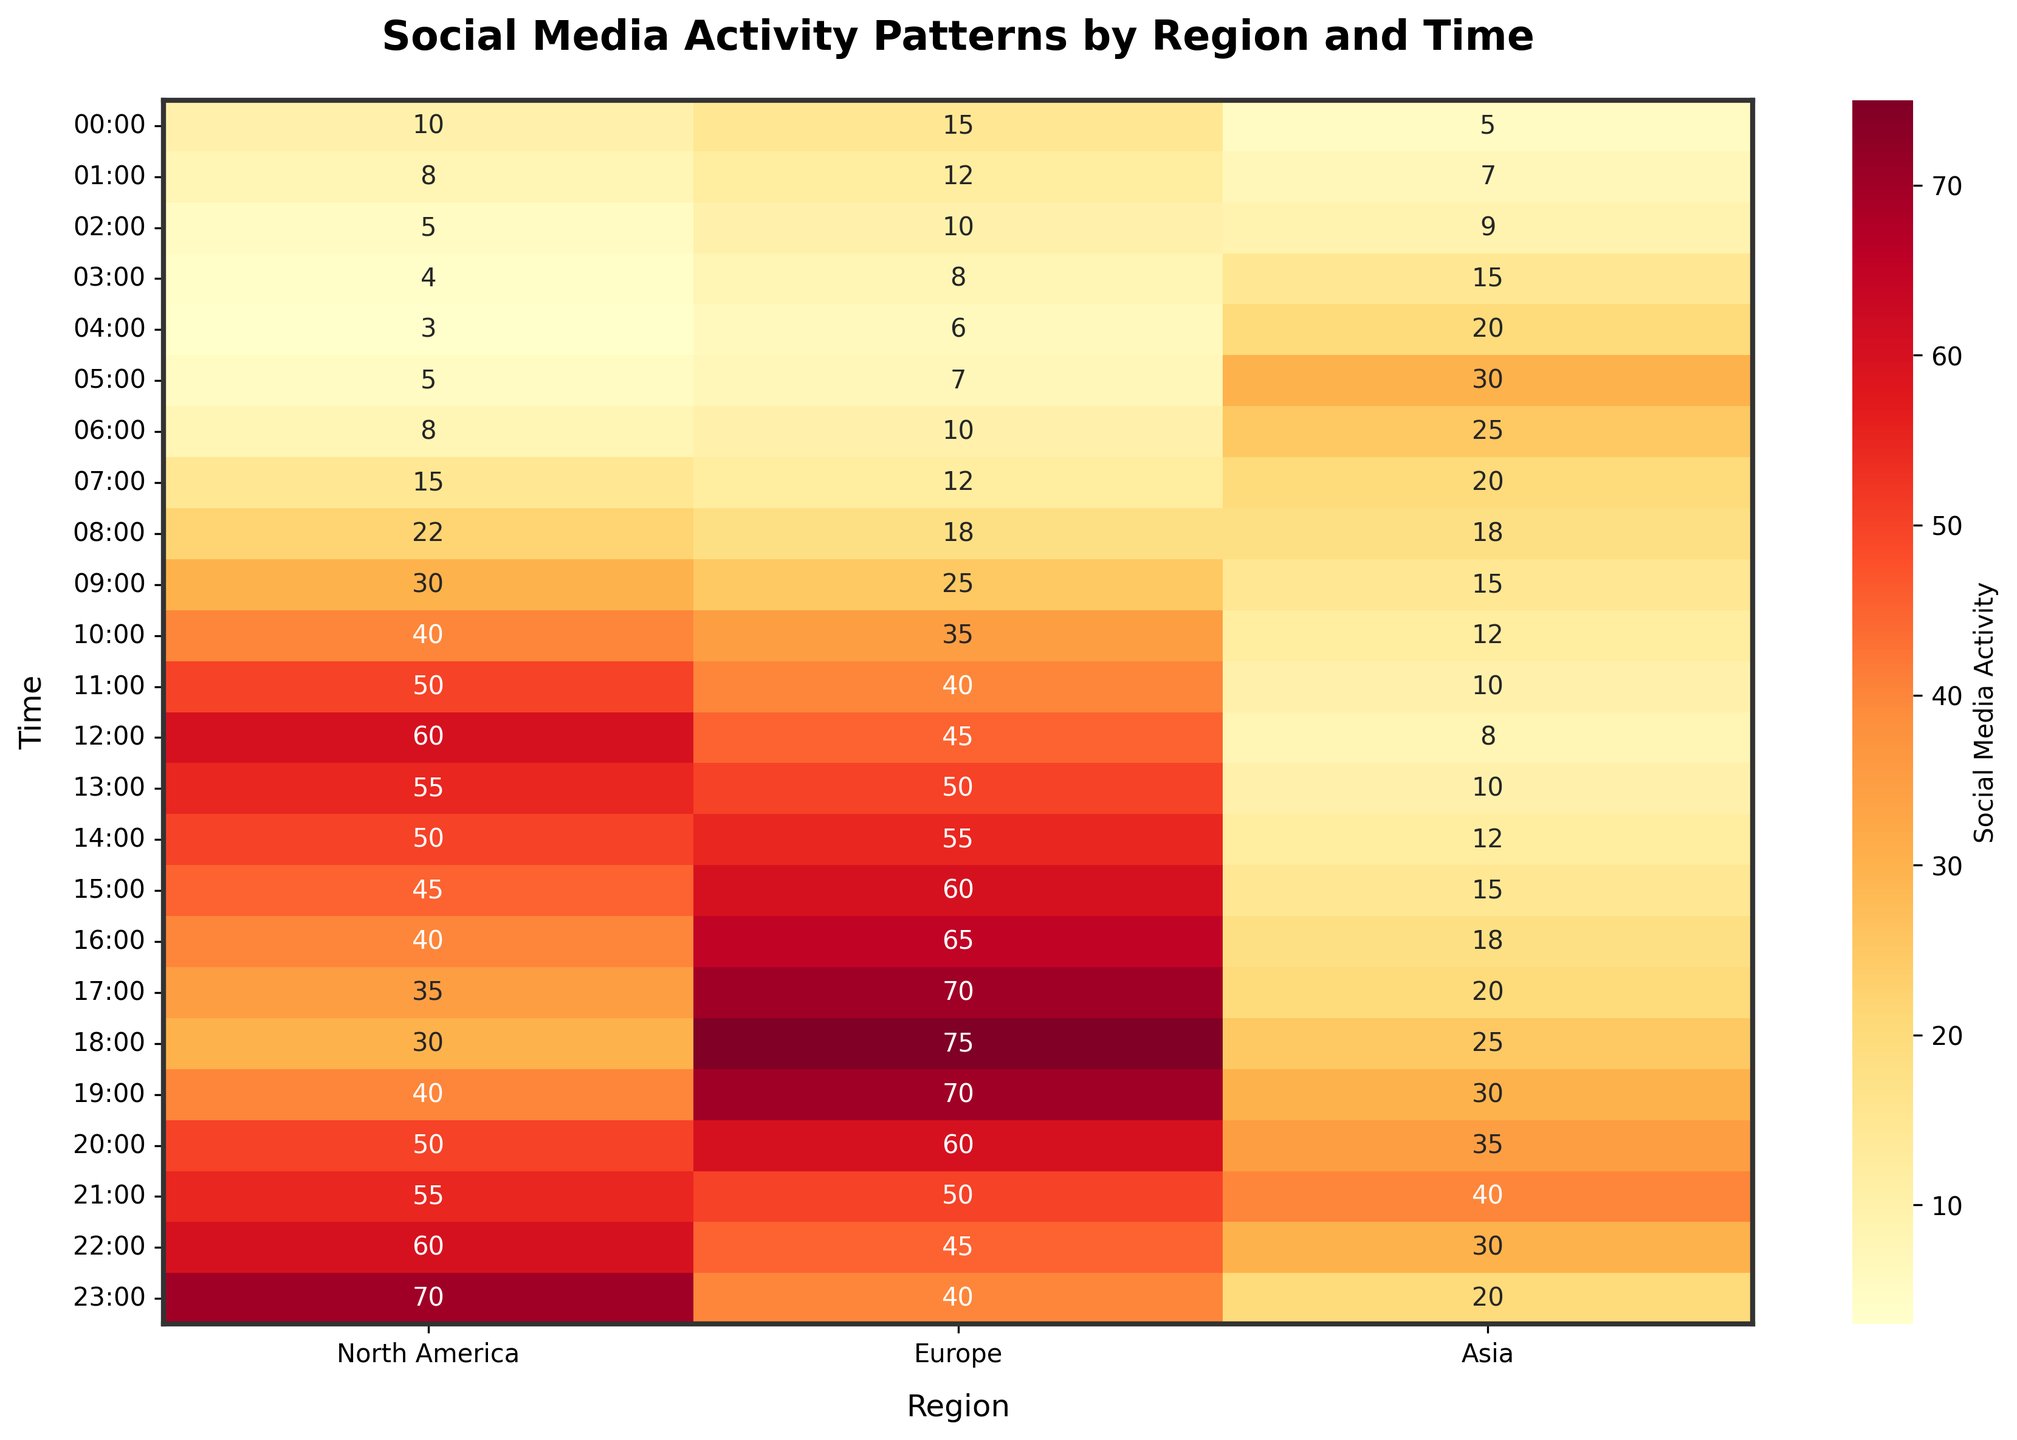What is the title of the heatmap? The title of the heatmap is displayed at the top and usually in a bold font. It reads "Social Media Activity Patterns by Region and Time".
Answer: Social Media Activity Patterns by Region and Time At what time does Europe have the highest social media activity? By looking at the values in the Europe column, the highest value is 75, which corresponds to the time 18:00.
Answer: 18:00 Which region has the least activity at 11:00? By observing the values in the row for 11:00, North America has 50, Europe has 40, and Asia has 10. Asia has the lowest value.
Answer: Asia What is the total social media activity in Asia at 04:00 and 05:00? To find the total, add the values at 04:00 and 05:00 in the Asia column. Thus, 20 + 30 = 50.
Answer: 50 How does the social media activity at 09:00 in North America compare to Asia? North America has a value of 30 at 09:00, and Asia has a value of 15 at the same time. Therefore, North America's activity is double that of Asia.
Answer: Double Which time period shows a steady increase in social media activity in Europe? A steady increase in Europe is seen from 14:00 to 18:00 where the values go from 55 to 75 consistently.
Answer: 14:00 to 18:00 What are the peak social media activity hours for North America? By examining the maximum value in the North America column, 70 is the highest which corresponds to 23:00.
Answer: 23:00 Compare the social media activity in Europe and Asia at 20:00. The value for Europe at 20:00 is 60, while for Asia it is 35. Thus, Europe's activity is higher than Asia's.
Answer: Europe has higher activity What is the average social media activity for North America between 08:00 and 12:00? Sum the values for North America from 08:00 to 12:00 (22, 30, 40, 50, 60) and divide by the number of data points. Thus, (22+30+40+50+60) / 5 = 40.4
Answer: 40.4 